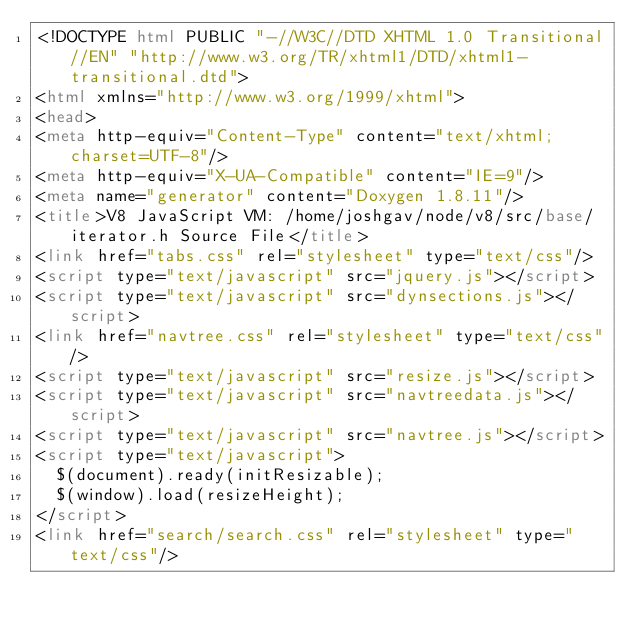<code> <loc_0><loc_0><loc_500><loc_500><_HTML_><!DOCTYPE html PUBLIC "-//W3C//DTD XHTML 1.0 Transitional//EN" "http://www.w3.org/TR/xhtml1/DTD/xhtml1-transitional.dtd">
<html xmlns="http://www.w3.org/1999/xhtml">
<head>
<meta http-equiv="Content-Type" content="text/xhtml;charset=UTF-8"/>
<meta http-equiv="X-UA-Compatible" content="IE=9"/>
<meta name="generator" content="Doxygen 1.8.11"/>
<title>V8 JavaScript VM: /home/joshgav/node/v8/src/base/iterator.h Source File</title>
<link href="tabs.css" rel="stylesheet" type="text/css"/>
<script type="text/javascript" src="jquery.js"></script>
<script type="text/javascript" src="dynsections.js"></script>
<link href="navtree.css" rel="stylesheet" type="text/css"/>
<script type="text/javascript" src="resize.js"></script>
<script type="text/javascript" src="navtreedata.js"></script>
<script type="text/javascript" src="navtree.js"></script>
<script type="text/javascript">
  $(document).ready(initResizable);
  $(window).load(resizeHeight);
</script>
<link href="search/search.css" rel="stylesheet" type="text/css"/></code> 